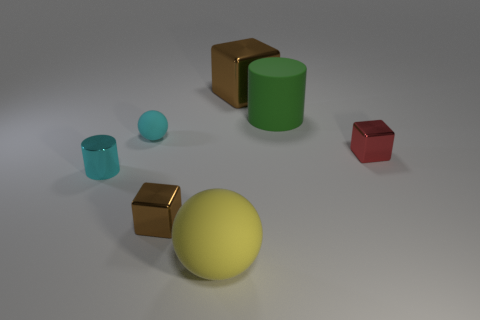Do the small cylinder and the tiny rubber thing have the same color?
Make the answer very short. Yes. There is a tiny cube that is the same color as the big cube; what material is it?
Give a very brief answer. Metal. What shape is the other tiny thing that is the same color as the tiny rubber thing?
Make the answer very short. Cylinder. How many cylinders have the same color as the tiny rubber ball?
Give a very brief answer. 1. What size is the sphere that is the same color as the metal cylinder?
Ensure brevity in your answer.  Small. Is the color of the big rubber thing right of the yellow rubber ball the same as the large metallic block?
Keep it short and to the point. No. There is a yellow rubber object that is the same shape as the tiny cyan matte thing; what is its size?
Make the answer very short. Large. Is there any other thing that is made of the same material as the red block?
Ensure brevity in your answer.  Yes. There is a tiny object on the right side of the small brown metal block that is to the right of the cyan rubber ball; are there any small cyan metal objects behind it?
Your answer should be very brief. No. What is the material of the small thing in front of the tiny cylinder?
Provide a succinct answer. Metal. 